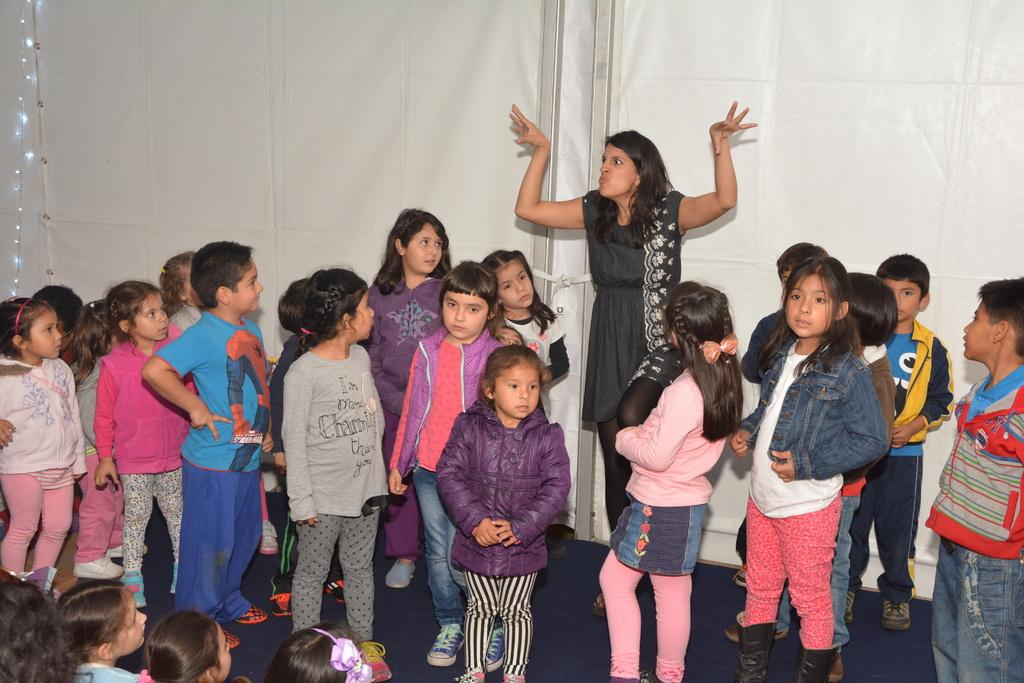Who is present in the image? There are children and a lady in the image. What can be seen in the background of the image? There are lights and a board visible in the background. What is the surface that the people are standing on in the image? The floor is visible at the bottom of the image. What type of dress is the passenger wearing in the image? There is no passenger present in the image, and therefore no dress can be described. 